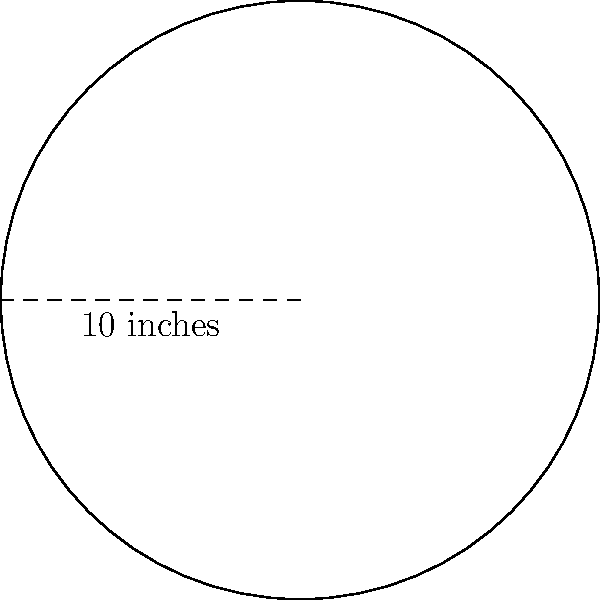You're preparing to make a homemade pizza and want to calculate the area of the circular base. If the diameter of your pizza is 10 inches, what is the area of the pizza base? (Use $\pi \approx 3.14$ and round your answer to the nearest square inch.) To find the area of a circular pizza base, we'll follow these steps:

1. Recall the formula for the area of a circle: $A = \pi r^2$, where $r$ is the radius.

2. We're given the diameter, which is 10 inches. The radius is half of the diameter:
   $r = \frac{10}{2} = 5$ inches

3. Now, let's substitute the values into the formula:
   $A = \pi r^2 = \pi \cdot 5^2 = \pi \cdot 25$

4. Using $\pi \approx 3.14$:
   $A \approx 3.14 \cdot 25 = 78.5$ square inches

5. Rounding to the nearest square inch:
   $A \approx 79$ square inches
Answer: 79 square inches 